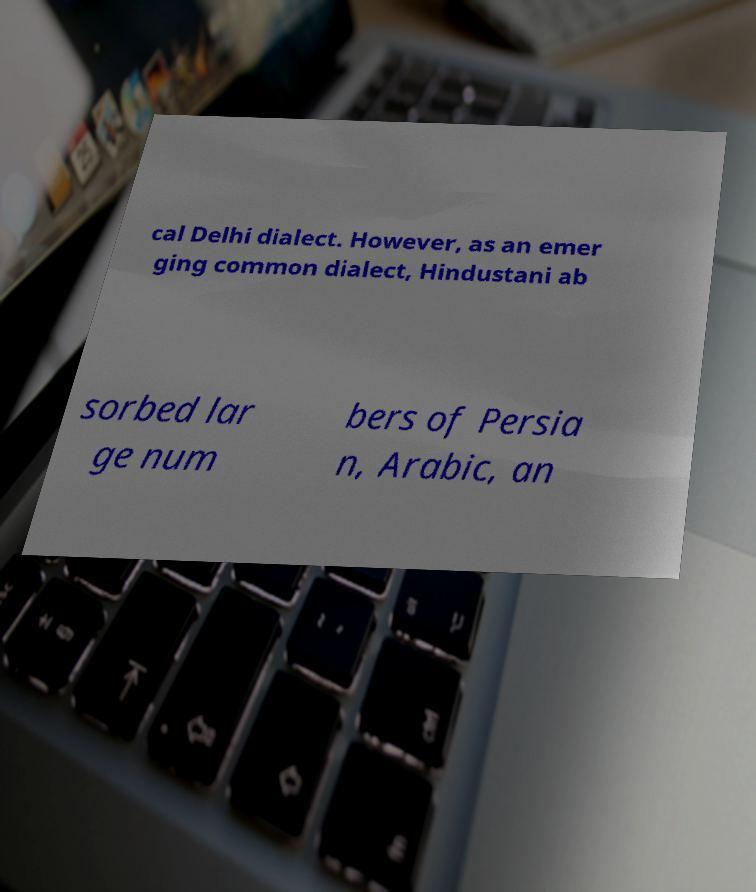What messages or text are displayed in this image? I need them in a readable, typed format. cal Delhi dialect. However, as an emer ging common dialect, Hindustani ab sorbed lar ge num bers of Persia n, Arabic, an 